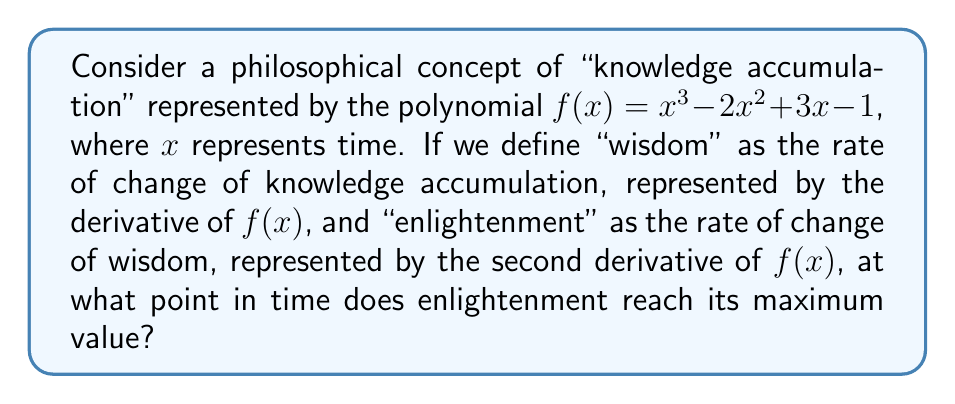Show me your answer to this math problem. To solve this problem, we need to follow these steps:

1) First, let's find the expression for "wisdom" by taking the first derivative of $f(x)$:

   $$f'(x) = 3x^2 - 4x + 3$$

   This represents the rate of change of knowledge accumulation, or "wisdom".

2) Now, let's find the expression for "enlightenment" by taking the second derivative of $f(x)$, which is the same as taking the first derivative of $f'(x)$:

   $$f''(x) = 6x - 4$$

   This represents the rate of change of wisdom, or "enlightenment".

3) To find the maximum value of enlightenment, we need to find where the rate of change of enlightenment is zero. In other words, we need to find the critical point of $f''(x)$ by taking its derivative and setting it equal to zero:

   $$\frac{d}{dx}(f''(x)) = 6 = 0$$

4) However, we see that this derivative is a constant (6), which means $f''(x)$ is always increasing at a constant rate. Therefore, $f''(x)$ doesn't have a maximum value in the traditional sense.

5) In this case, we can interpret the question as asking at what point $f''(x)$ becomes positive, which would represent the transition from decreasing to increasing enlightenment. We can find this by setting $f''(x) = 0$ and solving for $x$:

   $$6x - 4 = 0$$
   $$6x = 4$$
   $$x = \frac{2}{3}$$

6) We can verify that $f''(x)$ is negative before this point and positive after it, confirming that this is indeed the transition point.

This result suggests that in this model, enlightenment starts increasing (becomes positive) after $\frac{2}{3}$ units of time have passed.
Answer: Enlightenment begins to increase at $x = \frac{2}{3}$ units of time. 